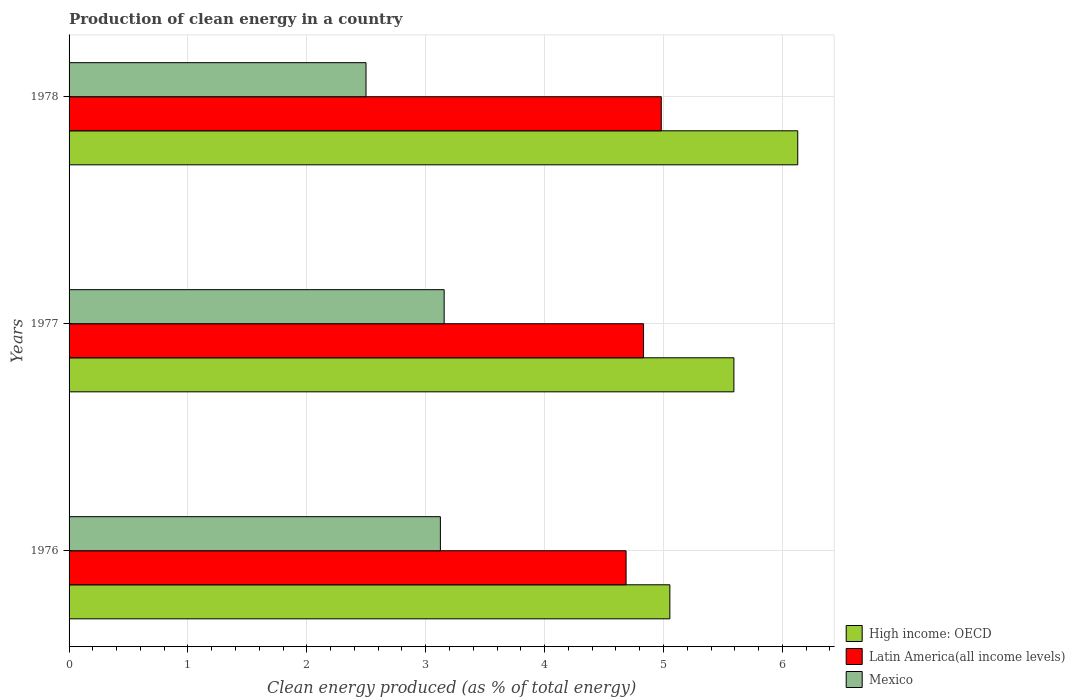How many different coloured bars are there?
Offer a very short reply. 3. How many groups of bars are there?
Your answer should be compact. 3. Are the number of bars on each tick of the Y-axis equal?
Offer a terse response. Yes. How many bars are there on the 3rd tick from the top?
Offer a terse response. 3. How many bars are there on the 3rd tick from the bottom?
Provide a short and direct response. 3. What is the label of the 2nd group of bars from the top?
Ensure brevity in your answer.  1977. In how many cases, is the number of bars for a given year not equal to the number of legend labels?
Provide a short and direct response. 0. What is the percentage of clean energy produced in Latin America(all income levels) in 1977?
Ensure brevity in your answer.  4.83. Across all years, what is the maximum percentage of clean energy produced in High income: OECD?
Ensure brevity in your answer.  6.13. Across all years, what is the minimum percentage of clean energy produced in High income: OECD?
Your answer should be very brief. 5.05. In which year was the percentage of clean energy produced in Latin America(all income levels) minimum?
Provide a short and direct response. 1976. What is the total percentage of clean energy produced in Latin America(all income levels) in the graph?
Keep it short and to the point. 14.5. What is the difference between the percentage of clean energy produced in High income: OECD in 1976 and that in 1977?
Keep it short and to the point. -0.54. What is the difference between the percentage of clean energy produced in High income: OECD in 1977 and the percentage of clean energy produced in Mexico in 1976?
Keep it short and to the point. 2.47. What is the average percentage of clean energy produced in Latin America(all income levels) per year?
Your response must be concise. 4.83. In the year 1978, what is the difference between the percentage of clean energy produced in High income: OECD and percentage of clean energy produced in Mexico?
Your answer should be compact. 3.63. In how many years, is the percentage of clean energy produced in High income: OECD greater than 3 %?
Your response must be concise. 3. What is the ratio of the percentage of clean energy produced in Latin America(all income levels) in 1976 to that in 1978?
Give a very brief answer. 0.94. What is the difference between the highest and the second highest percentage of clean energy produced in Latin America(all income levels)?
Keep it short and to the point. 0.15. What is the difference between the highest and the lowest percentage of clean energy produced in Mexico?
Provide a succinct answer. 0.66. What does the 1st bar from the top in 1977 represents?
Your answer should be compact. Mexico. What does the 2nd bar from the bottom in 1976 represents?
Your answer should be compact. Latin America(all income levels). Is it the case that in every year, the sum of the percentage of clean energy produced in Mexico and percentage of clean energy produced in High income: OECD is greater than the percentage of clean energy produced in Latin America(all income levels)?
Offer a very short reply. Yes. How many bars are there?
Make the answer very short. 9. Are all the bars in the graph horizontal?
Offer a very short reply. Yes. How many years are there in the graph?
Your answer should be compact. 3. Does the graph contain any zero values?
Provide a short and direct response. No. How many legend labels are there?
Give a very brief answer. 3. How are the legend labels stacked?
Offer a very short reply. Vertical. What is the title of the graph?
Your answer should be very brief. Production of clean energy in a country. Does "Argentina" appear as one of the legend labels in the graph?
Make the answer very short. No. What is the label or title of the X-axis?
Provide a short and direct response. Clean energy produced (as % of total energy). What is the Clean energy produced (as % of total energy) of High income: OECD in 1976?
Offer a terse response. 5.05. What is the Clean energy produced (as % of total energy) of Latin America(all income levels) in 1976?
Keep it short and to the point. 4.69. What is the Clean energy produced (as % of total energy) of Mexico in 1976?
Provide a short and direct response. 3.12. What is the Clean energy produced (as % of total energy) of High income: OECD in 1977?
Provide a short and direct response. 5.59. What is the Clean energy produced (as % of total energy) of Latin America(all income levels) in 1977?
Ensure brevity in your answer.  4.83. What is the Clean energy produced (as % of total energy) in Mexico in 1977?
Offer a terse response. 3.16. What is the Clean energy produced (as % of total energy) in High income: OECD in 1978?
Ensure brevity in your answer.  6.13. What is the Clean energy produced (as % of total energy) of Latin America(all income levels) in 1978?
Provide a succinct answer. 4.98. What is the Clean energy produced (as % of total energy) in Mexico in 1978?
Your answer should be compact. 2.5. Across all years, what is the maximum Clean energy produced (as % of total energy) of High income: OECD?
Offer a terse response. 6.13. Across all years, what is the maximum Clean energy produced (as % of total energy) in Latin America(all income levels)?
Make the answer very short. 4.98. Across all years, what is the maximum Clean energy produced (as % of total energy) of Mexico?
Give a very brief answer. 3.16. Across all years, what is the minimum Clean energy produced (as % of total energy) in High income: OECD?
Provide a short and direct response. 5.05. Across all years, what is the minimum Clean energy produced (as % of total energy) in Latin America(all income levels)?
Provide a short and direct response. 4.69. Across all years, what is the minimum Clean energy produced (as % of total energy) of Mexico?
Your answer should be compact. 2.5. What is the total Clean energy produced (as % of total energy) of High income: OECD in the graph?
Your answer should be very brief. 16.78. What is the total Clean energy produced (as % of total energy) in Latin America(all income levels) in the graph?
Provide a short and direct response. 14.5. What is the total Clean energy produced (as % of total energy) in Mexico in the graph?
Your response must be concise. 8.78. What is the difference between the Clean energy produced (as % of total energy) in High income: OECD in 1976 and that in 1977?
Offer a terse response. -0.54. What is the difference between the Clean energy produced (as % of total energy) in Latin America(all income levels) in 1976 and that in 1977?
Offer a very short reply. -0.15. What is the difference between the Clean energy produced (as % of total energy) of Mexico in 1976 and that in 1977?
Offer a terse response. -0.03. What is the difference between the Clean energy produced (as % of total energy) of High income: OECD in 1976 and that in 1978?
Make the answer very short. -1.08. What is the difference between the Clean energy produced (as % of total energy) in Latin America(all income levels) in 1976 and that in 1978?
Your answer should be compact. -0.3. What is the difference between the Clean energy produced (as % of total energy) in Mexico in 1976 and that in 1978?
Provide a succinct answer. 0.63. What is the difference between the Clean energy produced (as % of total energy) in High income: OECD in 1977 and that in 1978?
Your answer should be very brief. -0.54. What is the difference between the Clean energy produced (as % of total energy) in Latin America(all income levels) in 1977 and that in 1978?
Your answer should be very brief. -0.15. What is the difference between the Clean energy produced (as % of total energy) in Mexico in 1977 and that in 1978?
Make the answer very short. 0.66. What is the difference between the Clean energy produced (as % of total energy) of High income: OECD in 1976 and the Clean energy produced (as % of total energy) of Latin America(all income levels) in 1977?
Provide a succinct answer. 0.22. What is the difference between the Clean energy produced (as % of total energy) of High income: OECD in 1976 and the Clean energy produced (as % of total energy) of Mexico in 1977?
Your answer should be very brief. 1.9. What is the difference between the Clean energy produced (as % of total energy) of Latin America(all income levels) in 1976 and the Clean energy produced (as % of total energy) of Mexico in 1977?
Provide a short and direct response. 1.53. What is the difference between the Clean energy produced (as % of total energy) of High income: OECD in 1976 and the Clean energy produced (as % of total energy) of Latin America(all income levels) in 1978?
Your response must be concise. 0.07. What is the difference between the Clean energy produced (as % of total energy) of High income: OECD in 1976 and the Clean energy produced (as % of total energy) of Mexico in 1978?
Your answer should be very brief. 2.56. What is the difference between the Clean energy produced (as % of total energy) in Latin America(all income levels) in 1976 and the Clean energy produced (as % of total energy) in Mexico in 1978?
Ensure brevity in your answer.  2.19. What is the difference between the Clean energy produced (as % of total energy) in High income: OECD in 1977 and the Clean energy produced (as % of total energy) in Latin America(all income levels) in 1978?
Ensure brevity in your answer.  0.61. What is the difference between the Clean energy produced (as % of total energy) in High income: OECD in 1977 and the Clean energy produced (as % of total energy) in Mexico in 1978?
Your answer should be very brief. 3.09. What is the difference between the Clean energy produced (as % of total energy) in Latin America(all income levels) in 1977 and the Clean energy produced (as % of total energy) in Mexico in 1978?
Provide a succinct answer. 2.33. What is the average Clean energy produced (as % of total energy) of High income: OECD per year?
Provide a succinct answer. 5.59. What is the average Clean energy produced (as % of total energy) of Latin America(all income levels) per year?
Make the answer very short. 4.83. What is the average Clean energy produced (as % of total energy) in Mexico per year?
Keep it short and to the point. 2.93. In the year 1976, what is the difference between the Clean energy produced (as % of total energy) of High income: OECD and Clean energy produced (as % of total energy) of Latin America(all income levels)?
Your response must be concise. 0.37. In the year 1976, what is the difference between the Clean energy produced (as % of total energy) of High income: OECD and Clean energy produced (as % of total energy) of Mexico?
Give a very brief answer. 1.93. In the year 1976, what is the difference between the Clean energy produced (as % of total energy) in Latin America(all income levels) and Clean energy produced (as % of total energy) in Mexico?
Offer a terse response. 1.56. In the year 1977, what is the difference between the Clean energy produced (as % of total energy) of High income: OECD and Clean energy produced (as % of total energy) of Latin America(all income levels)?
Give a very brief answer. 0.76. In the year 1977, what is the difference between the Clean energy produced (as % of total energy) in High income: OECD and Clean energy produced (as % of total energy) in Mexico?
Your answer should be compact. 2.44. In the year 1977, what is the difference between the Clean energy produced (as % of total energy) of Latin America(all income levels) and Clean energy produced (as % of total energy) of Mexico?
Ensure brevity in your answer.  1.68. In the year 1978, what is the difference between the Clean energy produced (as % of total energy) of High income: OECD and Clean energy produced (as % of total energy) of Latin America(all income levels)?
Give a very brief answer. 1.15. In the year 1978, what is the difference between the Clean energy produced (as % of total energy) of High income: OECD and Clean energy produced (as % of total energy) of Mexico?
Provide a short and direct response. 3.63. In the year 1978, what is the difference between the Clean energy produced (as % of total energy) in Latin America(all income levels) and Clean energy produced (as % of total energy) in Mexico?
Offer a very short reply. 2.48. What is the ratio of the Clean energy produced (as % of total energy) in High income: OECD in 1976 to that in 1977?
Keep it short and to the point. 0.9. What is the ratio of the Clean energy produced (as % of total energy) of Latin America(all income levels) in 1976 to that in 1977?
Provide a short and direct response. 0.97. What is the ratio of the Clean energy produced (as % of total energy) of High income: OECD in 1976 to that in 1978?
Your answer should be very brief. 0.82. What is the ratio of the Clean energy produced (as % of total energy) in Latin America(all income levels) in 1976 to that in 1978?
Your answer should be very brief. 0.94. What is the ratio of the Clean energy produced (as % of total energy) in Mexico in 1976 to that in 1978?
Keep it short and to the point. 1.25. What is the ratio of the Clean energy produced (as % of total energy) of High income: OECD in 1977 to that in 1978?
Your answer should be compact. 0.91. What is the ratio of the Clean energy produced (as % of total energy) in Mexico in 1977 to that in 1978?
Keep it short and to the point. 1.26. What is the difference between the highest and the second highest Clean energy produced (as % of total energy) in High income: OECD?
Keep it short and to the point. 0.54. What is the difference between the highest and the second highest Clean energy produced (as % of total energy) in Latin America(all income levels)?
Provide a short and direct response. 0.15. What is the difference between the highest and the second highest Clean energy produced (as % of total energy) of Mexico?
Make the answer very short. 0.03. What is the difference between the highest and the lowest Clean energy produced (as % of total energy) of High income: OECD?
Ensure brevity in your answer.  1.08. What is the difference between the highest and the lowest Clean energy produced (as % of total energy) of Latin America(all income levels)?
Make the answer very short. 0.3. What is the difference between the highest and the lowest Clean energy produced (as % of total energy) in Mexico?
Give a very brief answer. 0.66. 